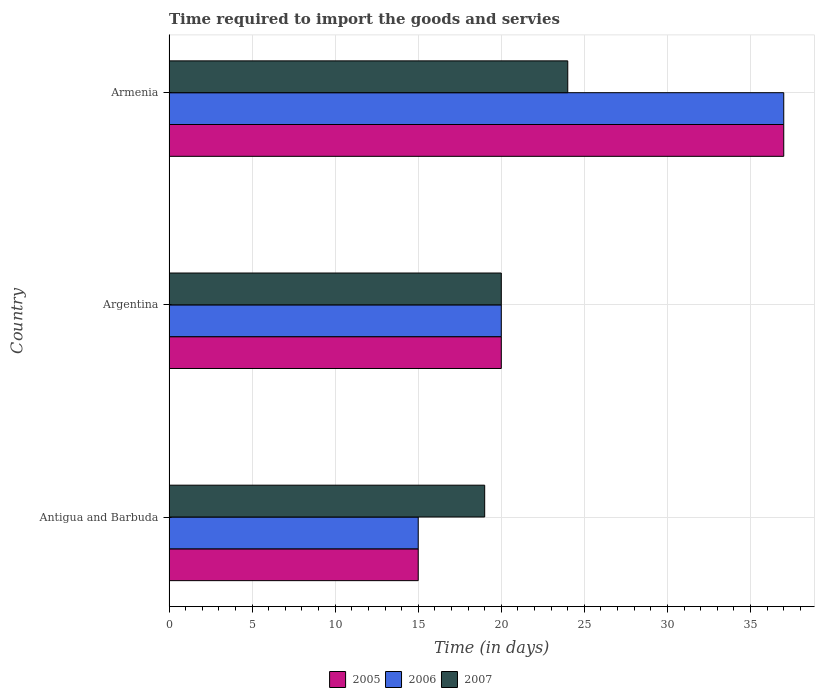How many different coloured bars are there?
Your answer should be compact. 3. How many groups of bars are there?
Make the answer very short. 3. Are the number of bars on each tick of the Y-axis equal?
Ensure brevity in your answer.  Yes. How many bars are there on the 1st tick from the top?
Your answer should be very brief. 3. How many bars are there on the 3rd tick from the bottom?
Your response must be concise. 3. What is the label of the 2nd group of bars from the top?
Keep it short and to the point. Argentina. In how many cases, is the number of bars for a given country not equal to the number of legend labels?
Your answer should be very brief. 0. Across all countries, what is the maximum number of days required to import the goods and services in 2007?
Offer a terse response. 24. Across all countries, what is the minimum number of days required to import the goods and services in 2006?
Your answer should be very brief. 15. In which country was the number of days required to import the goods and services in 2005 maximum?
Provide a short and direct response. Armenia. In which country was the number of days required to import the goods and services in 2006 minimum?
Keep it short and to the point. Antigua and Barbuda. What is the total number of days required to import the goods and services in 2005 in the graph?
Offer a very short reply. 72. What is the difference between the number of days required to import the goods and services in 2005 in Argentina and that in Armenia?
Offer a very short reply. -17. What is the average number of days required to import the goods and services in 2005 per country?
Your answer should be very brief. 24. What is the difference between the number of days required to import the goods and services in 2007 and number of days required to import the goods and services in 2005 in Argentina?
Ensure brevity in your answer.  0. In how many countries, is the number of days required to import the goods and services in 2006 greater than 3 days?
Keep it short and to the point. 3. What is the ratio of the number of days required to import the goods and services in 2005 in Antigua and Barbuda to that in Armenia?
Your response must be concise. 0.41. Is the number of days required to import the goods and services in 2006 in Antigua and Barbuda less than that in Argentina?
Your answer should be compact. Yes. Is the difference between the number of days required to import the goods and services in 2007 in Antigua and Barbuda and Armenia greater than the difference between the number of days required to import the goods and services in 2005 in Antigua and Barbuda and Armenia?
Your answer should be compact. Yes. What is the difference between the highest and the second highest number of days required to import the goods and services in 2006?
Your response must be concise. 17. What is the difference between the highest and the lowest number of days required to import the goods and services in 2007?
Your answer should be compact. 5. What does the 2nd bar from the top in Argentina represents?
Offer a terse response. 2006. How many bars are there?
Your response must be concise. 9. Are all the bars in the graph horizontal?
Your answer should be very brief. Yes. How many countries are there in the graph?
Offer a very short reply. 3. Does the graph contain any zero values?
Provide a short and direct response. No. Where does the legend appear in the graph?
Your response must be concise. Bottom center. How are the legend labels stacked?
Your answer should be compact. Horizontal. What is the title of the graph?
Your answer should be very brief. Time required to import the goods and servies. Does "1996" appear as one of the legend labels in the graph?
Your answer should be compact. No. What is the label or title of the X-axis?
Give a very brief answer. Time (in days). What is the Time (in days) of 2005 in Antigua and Barbuda?
Your response must be concise. 15. What is the Time (in days) of 2006 in Antigua and Barbuda?
Ensure brevity in your answer.  15. What is the Time (in days) of 2007 in Antigua and Barbuda?
Provide a short and direct response. 19. What is the Time (in days) of 2005 in Argentina?
Your answer should be very brief. 20. What is the Time (in days) in 2006 in Argentina?
Offer a terse response. 20. What is the Time (in days) in 2007 in Argentina?
Your response must be concise. 20. What is the Time (in days) in 2006 in Armenia?
Make the answer very short. 37. Across all countries, what is the maximum Time (in days) in 2006?
Offer a terse response. 37. Across all countries, what is the minimum Time (in days) in 2005?
Your answer should be compact. 15. Across all countries, what is the minimum Time (in days) in 2006?
Offer a very short reply. 15. Across all countries, what is the minimum Time (in days) in 2007?
Offer a very short reply. 19. What is the total Time (in days) of 2005 in the graph?
Your answer should be very brief. 72. What is the total Time (in days) in 2006 in the graph?
Your answer should be very brief. 72. What is the difference between the Time (in days) of 2006 in Antigua and Barbuda and that in Argentina?
Your answer should be compact. -5. What is the difference between the Time (in days) of 2007 in Antigua and Barbuda and that in Argentina?
Provide a short and direct response. -1. What is the difference between the Time (in days) in 2005 in Antigua and Barbuda and that in Armenia?
Provide a short and direct response. -22. What is the difference between the Time (in days) of 2006 in Antigua and Barbuda and that in Armenia?
Your response must be concise. -22. What is the difference between the Time (in days) in 2007 in Antigua and Barbuda and that in Armenia?
Your answer should be very brief. -5. What is the difference between the Time (in days) in 2005 in Argentina and that in Armenia?
Your answer should be compact. -17. What is the difference between the Time (in days) in 2007 in Argentina and that in Armenia?
Ensure brevity in your answer.  -4. What is the difference between the Time (in days) in 2006 in Antigua and Barbuda and the Time (in days) in 2007 in Argentina?
Offer a very short reply. -5. What is the difference between the Time (in days) of 2005 in Antigua and Barbuda and the Time (in days) of 2006 in Armenia?
Offer a very short reply. -22. What is the difference between the Time (in days) in 2005 in Antigua and Barbuda and the Time (in days) in 2007 in Armenia?
Offer a terse response. -9. What is the difference between the Time (in days) of 2005 in Argentina and the Time (in days) of 2006 in Armenia?
Keep it short and to the point. -17. What is the difference between the Time (in days) of 2006 in Argentina and the Time (in days) of 2007 in Armenia?
Keep it short and to the point. -4. What is the average Time (in days) in 2006 per country?
Provide a short and direct response. 24. What is the difference between the Time (in days) in 2005 and Time (in days) in 2006 in Antigua and Barbuda?
Offer a terse response. 0. What is the difference between the Time (in days) in 2005 and Time (in days) in 2006 in Argentina?
Give a very brief answer. 0. What is the difference between the Time (in days) of 2005 and Time (in days) of 2007 in Argentina?
Make the answer very short. 0. What is the difference between the Time (in days) of 2006 and Time (in days) of 2007 in Argentina?
Provide a short and direct response. 0. What is the difference between the Time (in days) of 2005 and Time (in days) of 2007 in Armenia?
Give a very brief answer. 13. What is the difference between the Time (in days) in 2006 and Time (in days) in 2007 in Armenia?
Make the answer very short. 13. What is the ratio of the Time (in days) of 2005 in Antigua and Barbuda to that in Argentina?
Offer a terse response. 0.75. What is the ratio of the Time (in days) of 2006 in Antigua and Barbuda to that in Argentina?
Your response must be concise. 0.75. What is the ratio of the Time (in days) in 2005 in Antigua and Barbuda to that in Armenia?
Your response must be concise. 0.41. What is the ratio of the Time (in days) of 2006 in Antigua and Barbuda to that in Armenia?
Make the answer very short. 0.41. What is the ratio of the Time (in days) in 2007 in Antigua and Barbuda to that in Armenia?
Your response must be concise. 0.79. What is the ratio of the Time (in days) in 2005 in Argentina to that in Armenia?
Keep it short and to the point. 0.54. What is the ratio of the Time (in days) of 2006 in Argentina to that in Armenia?
Offer a very short reply. 0.54. What is the difference between the highest and the second highest Time (in days) of 2006?
Give a very brief answer. 17. What is the difference between the highest and the second highest Time (in days) in 2007?
Give a very brief answer. 4. What is the difference between the highest and the lowest Time (in days) of 2005?
Your answer should be very brief. 22. What is the difference between the highest and the lowest Time (in days) of 2006?
Keep it short and to the point. 22. 